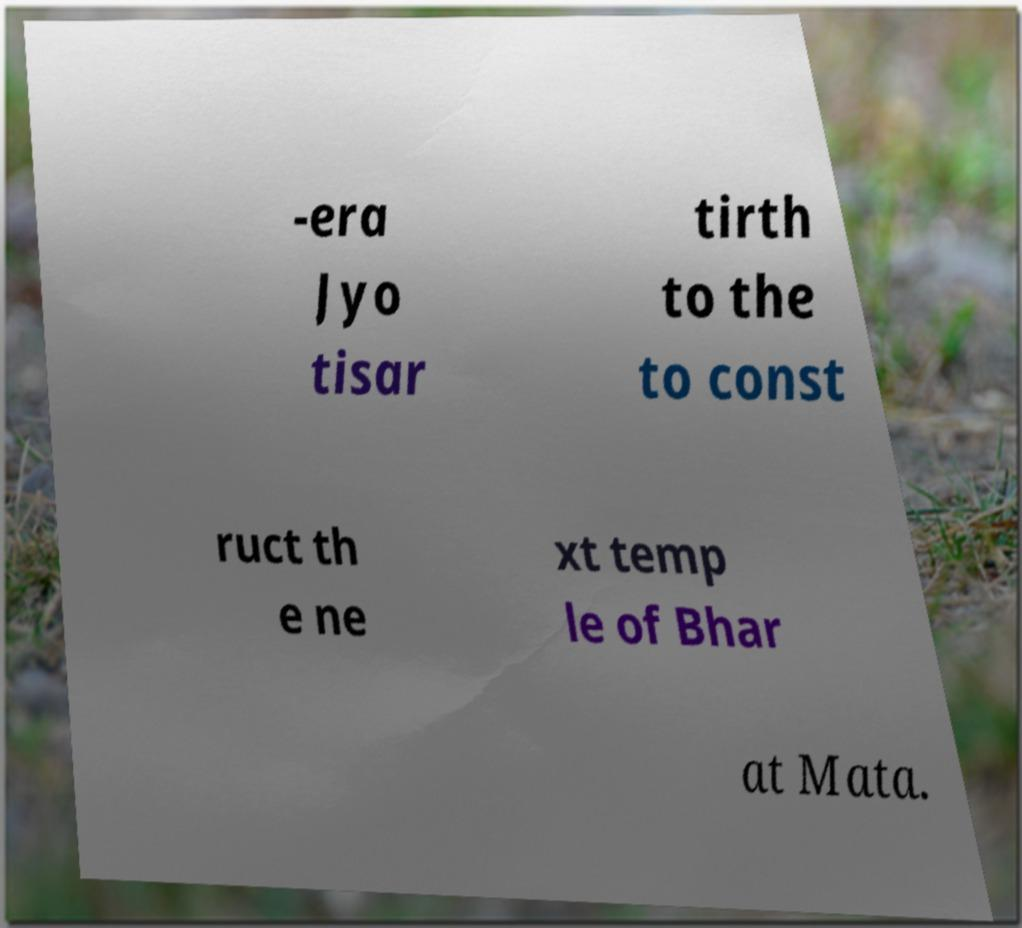For documentation purposes, I need the text within this image transcribed. Could you provide that? -era Jyo tisar tirth to the to const ruct th e ne xt temp le of Bhar at Mata. 